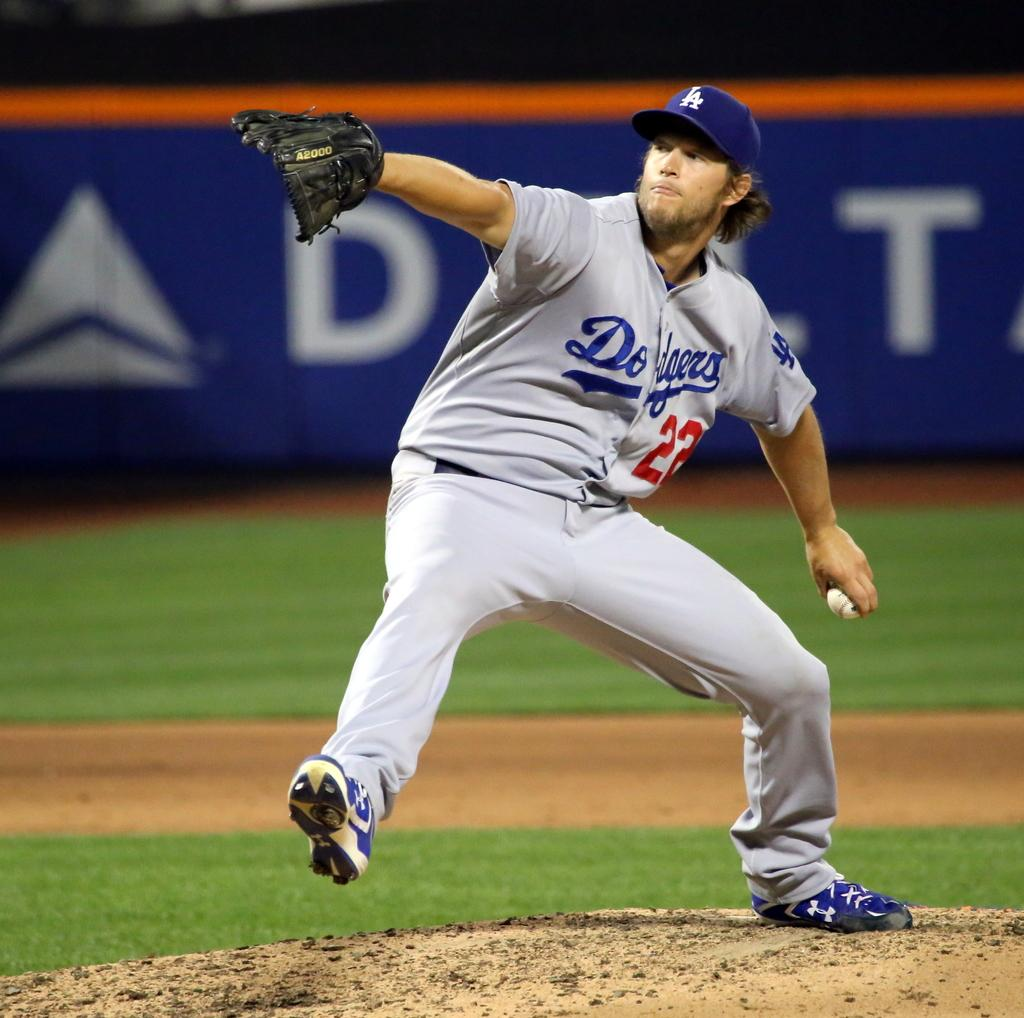<image>
Present a compact description of the photo's key features. A Dodgers baseball player wearing 22 prepares to throw the ball 